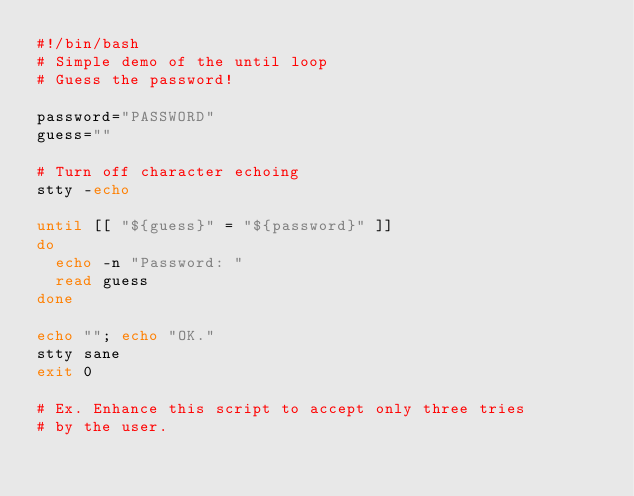<code> <loc_0><loc_0><loc_500><loc_500><_Bash_>#!/bin/bash
# Simple demo of the until loop
# Guess the password!

password="PASSWORD"
guess=""

# Turn off character echoing
stty -echo

until [[ "${guess}" = "${password}" ]]
do
	echo -n "Password: "
	read guess
done

echo ""; echo "OK."
stty sane
exit 0

# Ex. Enhance this script to accept only three tries
# by the user.
</code> 